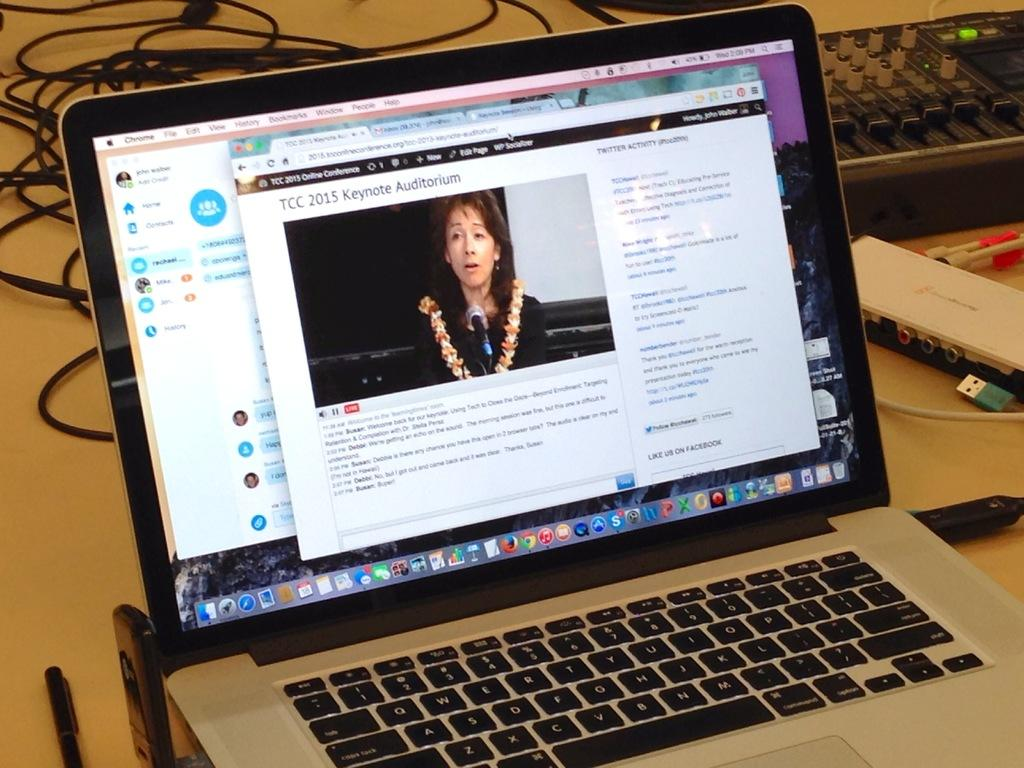<image>
Relay a brief, clear account of the picture shown. A laptop computer is displaying the website for the TCC 2015 Keynote Auditorium. 